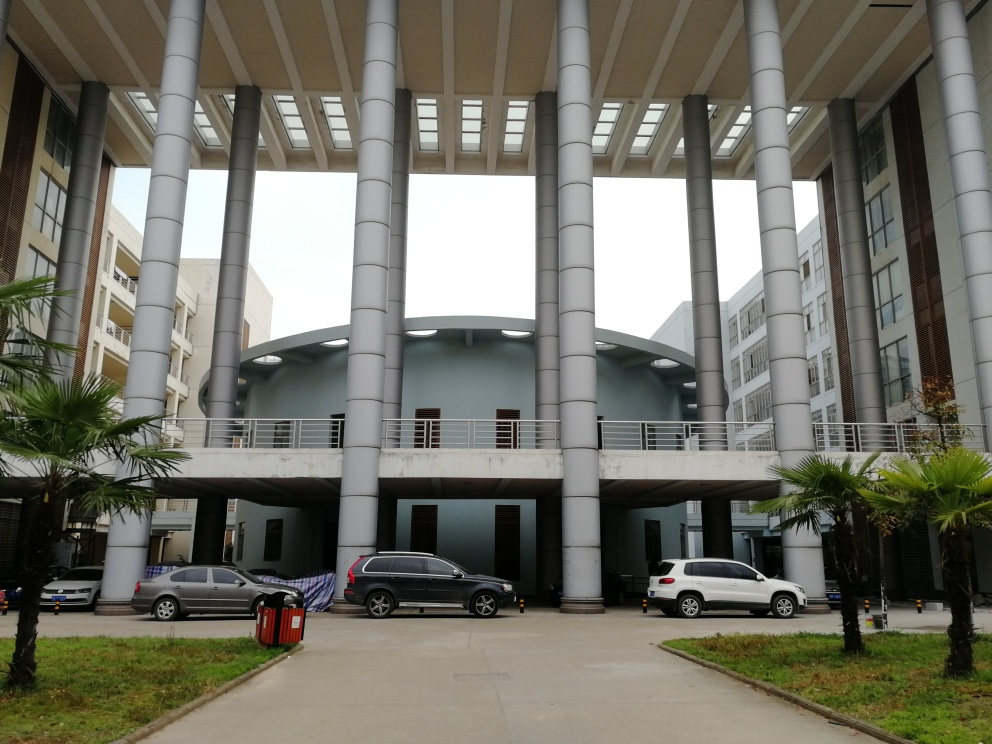Are there any features in this image that suggest this location is well-maintained? Yes, there are multiple indicators of regular maintenance. The buildings and walkways show no apparent signs of wear or damage. The cars are parked in an orderly fashion, and the landscaping, including the trimmed palm trees and manicured grass, is well-kept. The visible trash receptacle is also a sign that there's infrastructure in place for keeping the area clean. 